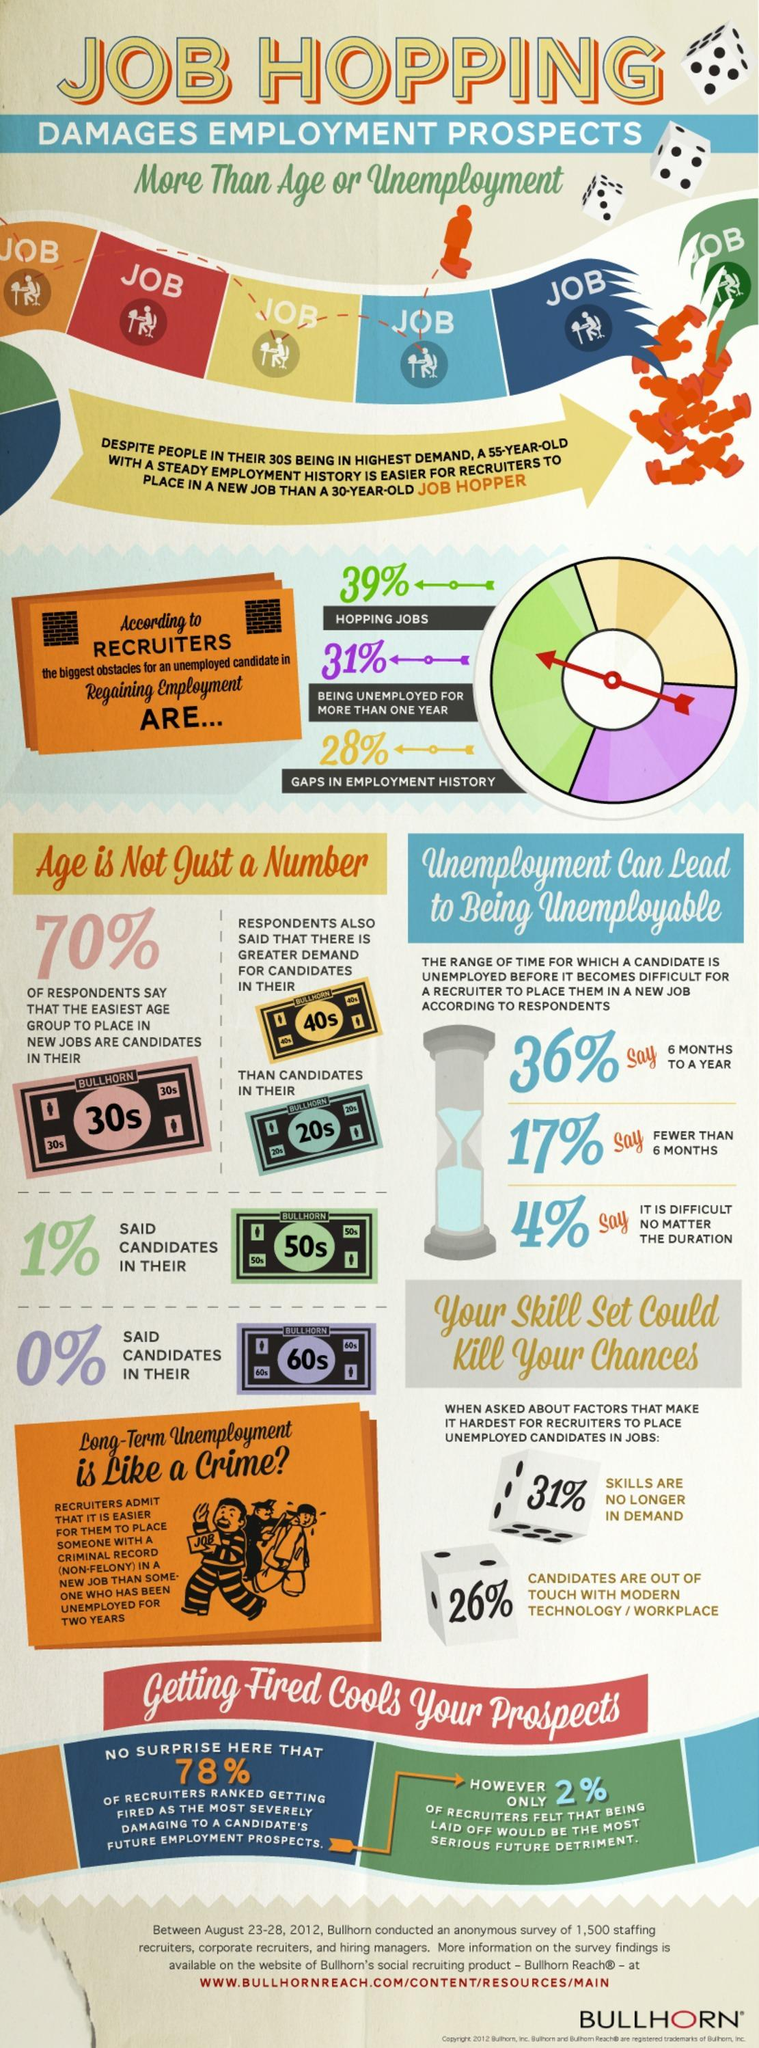What percentage of respondents in the Bullhorn survey say that the easiest age group to place in new jobs are candidates in their 50s?
Answer the question with a short phrase. 1% What percentage of respondents in the Bullhorn survey say that the easiest age group to place in new jobs are candidates in their 60s? 0% Which age group candidates are in greater demand in the job market according to the Bullhorn survey conducted? 40s Which is the easiest age group to get into a new job according to 70% of the respondents of the Bullhorn survey? 30s What percentage of recruiters think that gaps in employment history is the biggest obstacle for an unemployed candidate in regaining employment according to the Bullhorn survey? 28% What percentage of candidates are not out of touch with the modern technology / workplace according to the Bullhorn survey conducted? 74% What percentage of recruiters think that hopping jobs is the biggest obstacle for an unemployed candidate in regaining employment according to the Bullhorn survey? 39% What percentage of recruiters think that being unemployed for more than one year is the biggest obstacle for an unemployed candidate in regaining employment according to the Bullhorn survey? 31% 